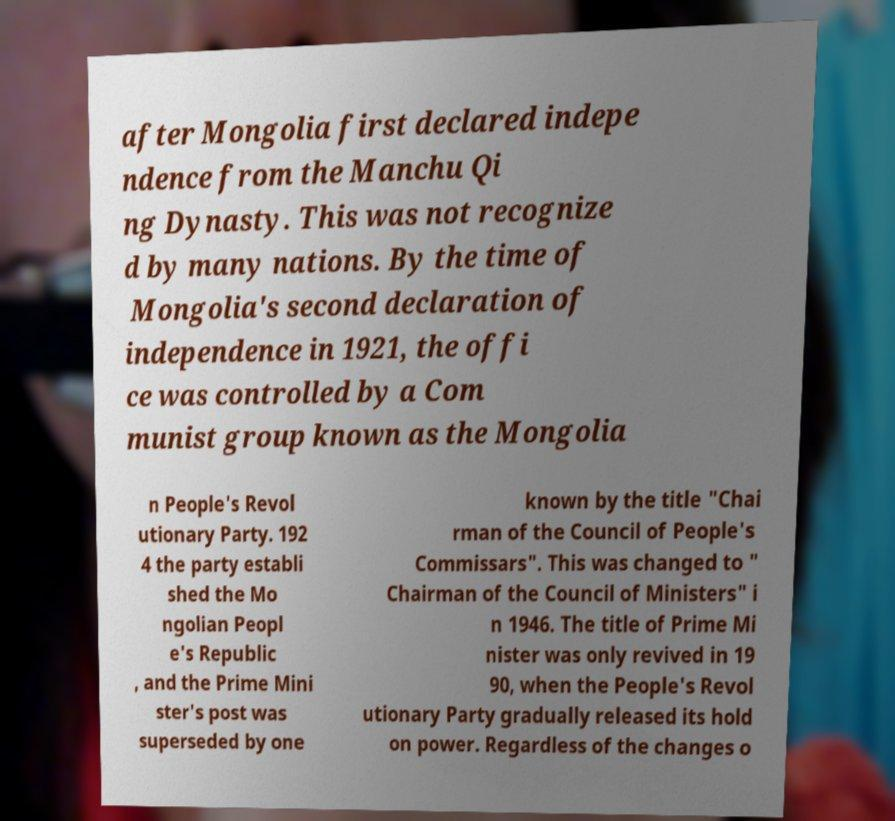Can you accurately transcribe the text from the provided image for me? after Mongolia first declared indepe ndence from the Manchu Qi ng Dynasty. This was not recognize d by many nations. By the time of Mongolia's second declaration of independence in 1921, the offi ce was controlled by a Com munist group known as the Mongolia n People's Revol utionary Party. 192 4 the party establi shed the Mo ngolian Peopl e's Republic , and the Prime Mini ster's post was superseded by one known by the title "Chai rman of the Council of People's Commissars". This was changed to " Chairman of the Council of Ministers" i n 1946. The title of Prime Mi nister was only revived in 19 90, when the People's Revol utionary Party gradually released its hold on power. Regardless of the changes o 